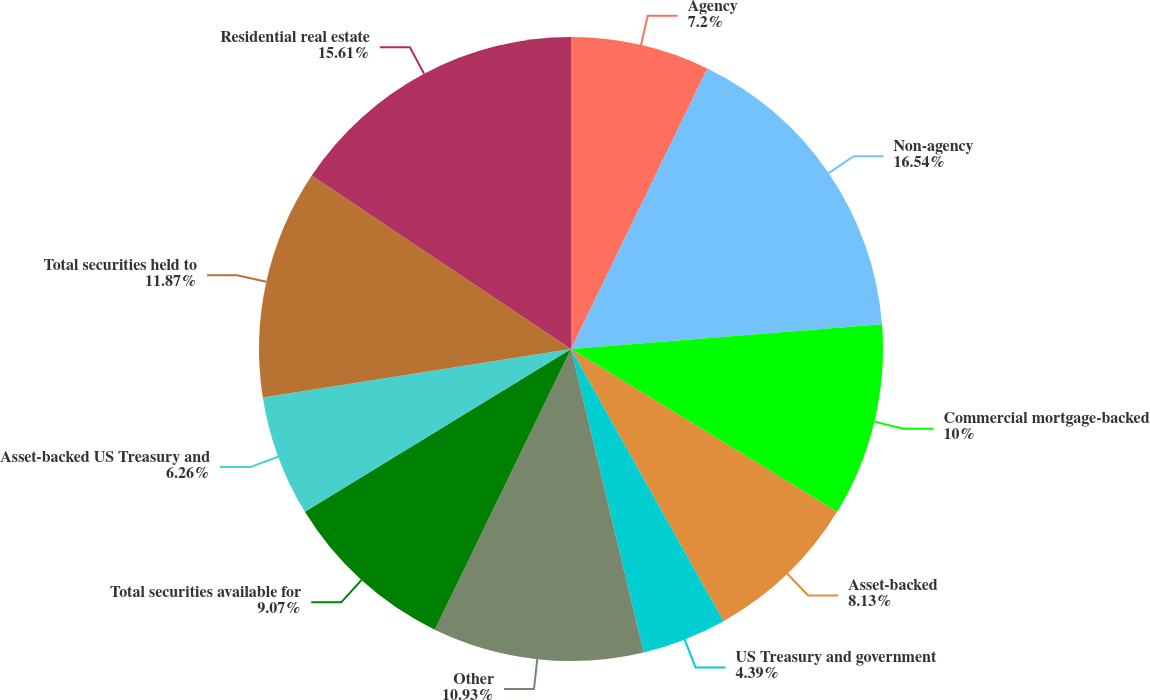Convert chart to OTSL. <chart><loc_0><loc_0><loc_500><loc_500><pie_chart><fcel>Agency<fcel>Non-agency<fcel>Commercial mortgage-backed<fcel>Asset-backed<fcel>US Treasury and government<fcel>Other<fcel>Total securities available for<fcel>Asset-backed US Treasury and<fcel>Total securities held to<fcel>Residential real estate<nl><fcel>7.2%<fcel>16.54%<fcel>10.0%<fcel>8.13%<fcel>4.39%<fcel>10.93%<fcel>9.07%<fcel>6.26%<fcel>11.87%<fcel>15.61%<nl></chart> 